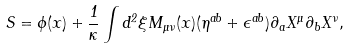Convert formula to latex. <formula><loc_0><loc_0><loc_500><loc_500>S = \phi ( x ) + \frac { 1 } { \kappa } \int d ^ { 2 } \xi M _ { \mu \nu } ( x ) ( \eta ^ { a b } + \epsilon ^ { a b } ) \partial _ { a } X ^ { \mu } \partial _ { b } X ^ { \nu } ,</formula> 